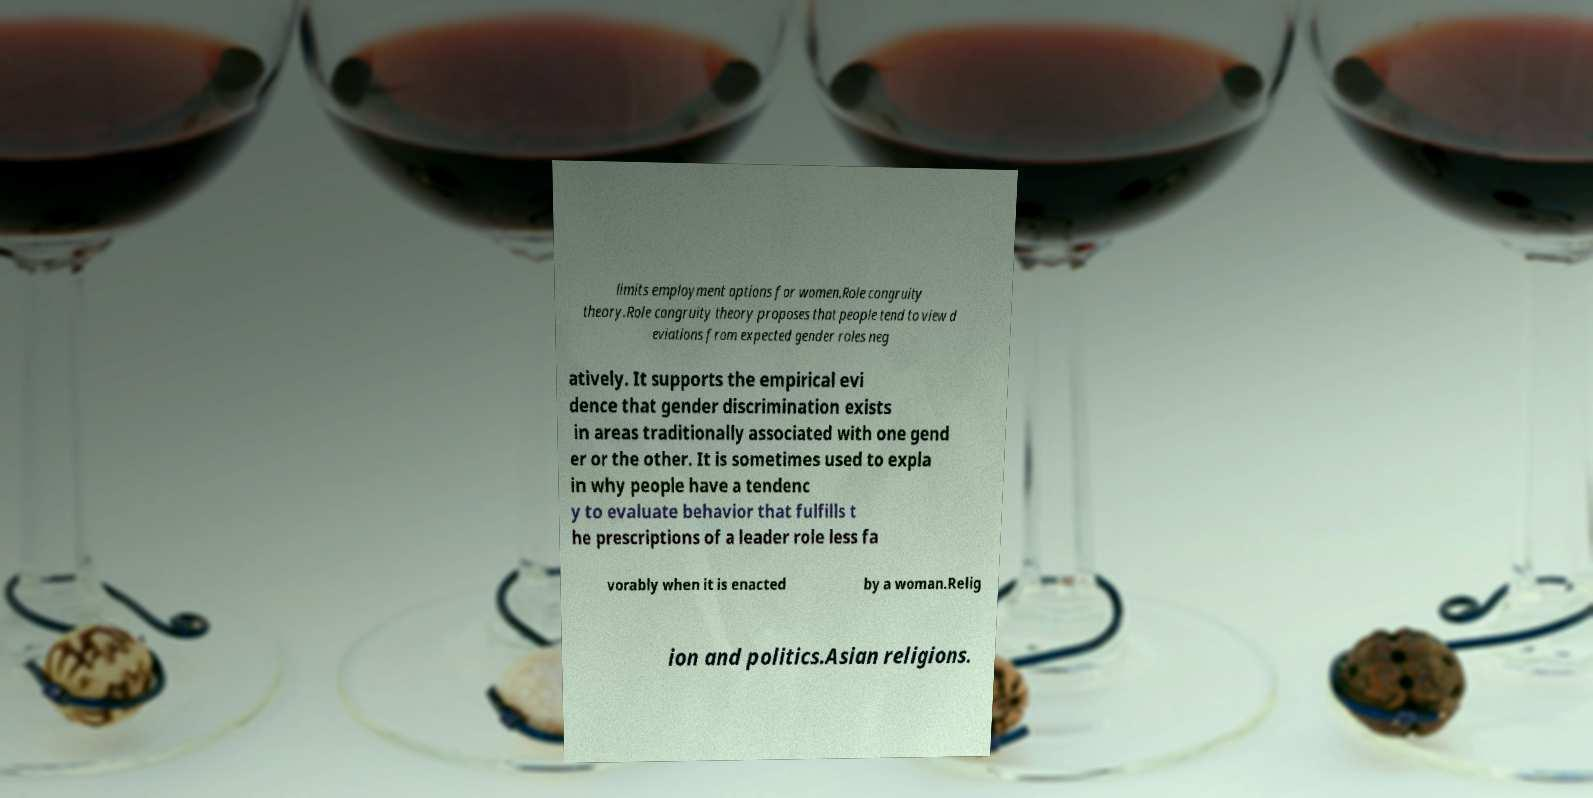I need the written content from this picture converted into text. Can you do that? limits employment options for women.Role congruity theory.Role congruity theory proposes that people tend to view d eviations from expected gender roles neg atively. It supports the empirical evi dence that gender discrimination exists in areas traditionally associated with one gend er or the other. It is sometimes used to expla in why people have a tendenc y to evaluate behavior that fulfills t he prescriptions of a leader role less fa vorably when it is enacted by a woman.Relig ion and politics.Asian religions. 